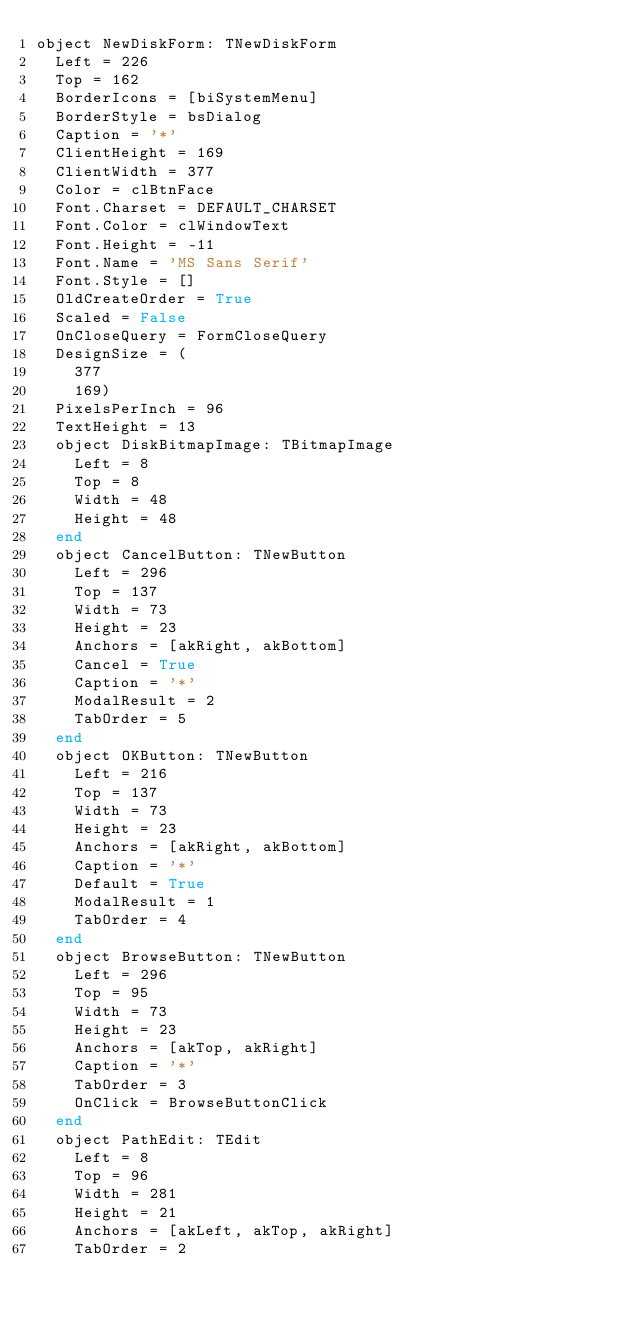<code> <loc_0><loc_0><loc_500><loc_500><_Pascal_>object NewDiskForm: TNewDiskForm
  Left = 226
  Top = 162
  BorderIcons = [biSystemMenu]
  BorderStyle = bsDialog
  Caption = '*'
  ClientHeight = 169
  ClientWidth = 377
  Color = clBtnFace
  Font.Charset = DEFAULT_CHARSET
  Font.Color = clWindowText
  Font.Height = -11
  Font.Name = 'MS Sans Serif'
  Font.Style = []
  OldCreateOrder = True
  Scaled = False
  OnCloseQuery = FormCloseQuery
  DesignSize = (
    377
    169)
  PixelsPerInch = 96
  TextHeight = 13
  object DiskBitmapImage: TBitmapImage
    Left = 8
    Top = 8
    Width = 48
    Height = 48
  end
  object CancelButton: TNewButton
    Left = 296
    Top = 137
    Width = 73
    Height = 23
    Anchors = [akRight, akBottom]
    Cancel = True
    Caption = '*'
    ModalResult = 2
    TabOrder = 5
  end
  object OKButton: TNewButton
    Left = 216
    Top = 137
    Width = 73
    Height = 23
    Anchors = [akRight, akBottom]
    Caption = '*'
    Default = True
    ModalResult = 1
    TabOrder = 4
  end
  object BrowseButton: TNewButton
    Left = 296
    Top = 95
    Width = 73
    Height = 23
    Anchors = [akTop, akRight]
    Caption = '*'
    TabOrder = 3
    OnClick = BrowseButtonClick
  end
  object PathEdit: TEdit
    Left = 8
    Top = 96
    Width = 281
    Height = 21
    Anchors = [akLeft, akTop, akRight]
    TabOrder = 2</code> 